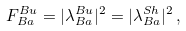Convert formula to latex. <formula><loc_0><loc_0><loc_500><loc_500>F _ { B a } ^ { B u } = | \lambda _ { B a } ^ { B u } | ^ { 2 } = | \lambda _ { B a } ^ { S h } | ^ { 2 } \, ,</formula> 